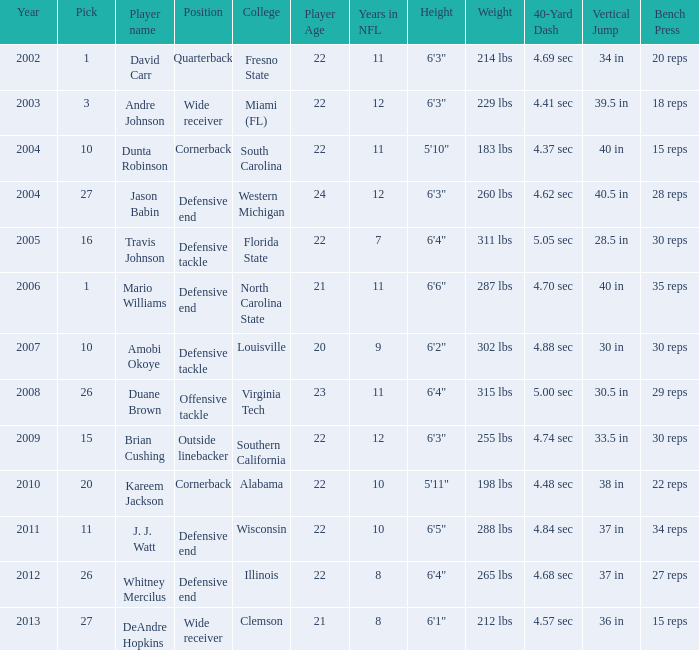What pick was mario williams before 2006? None. 